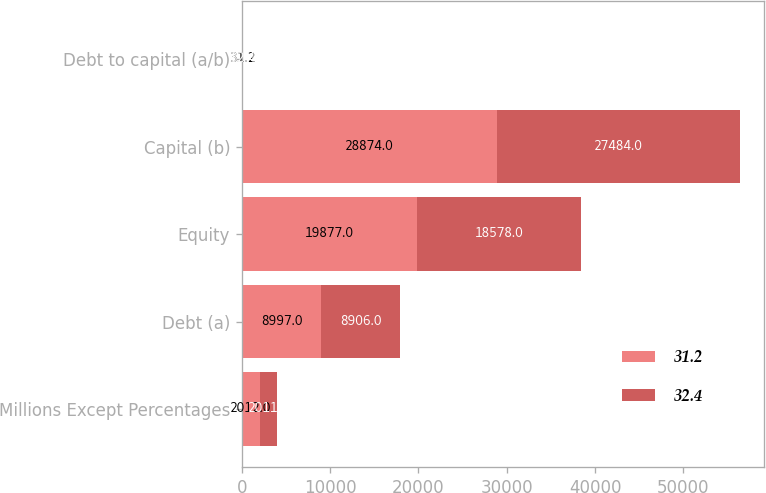<chart> <loc_0><loc_0><loc_500><loc_500><stacked_bar_chart><ecel><fcel>Millions Except Percentages<fcel>Debt (a)<fcel>Equity<fcel>Capital (b)<fcel>Debt to capital (a/b)<nl><fcel>31.2<fcel>2012<fcel>8997<fcel>19877<fcel>28874<fcel>31.2<nl><fcel>32.4<fcel>2011<fcel>8906<fcel>18578<fcel>27484<fcel>32.4<nl></chart> 